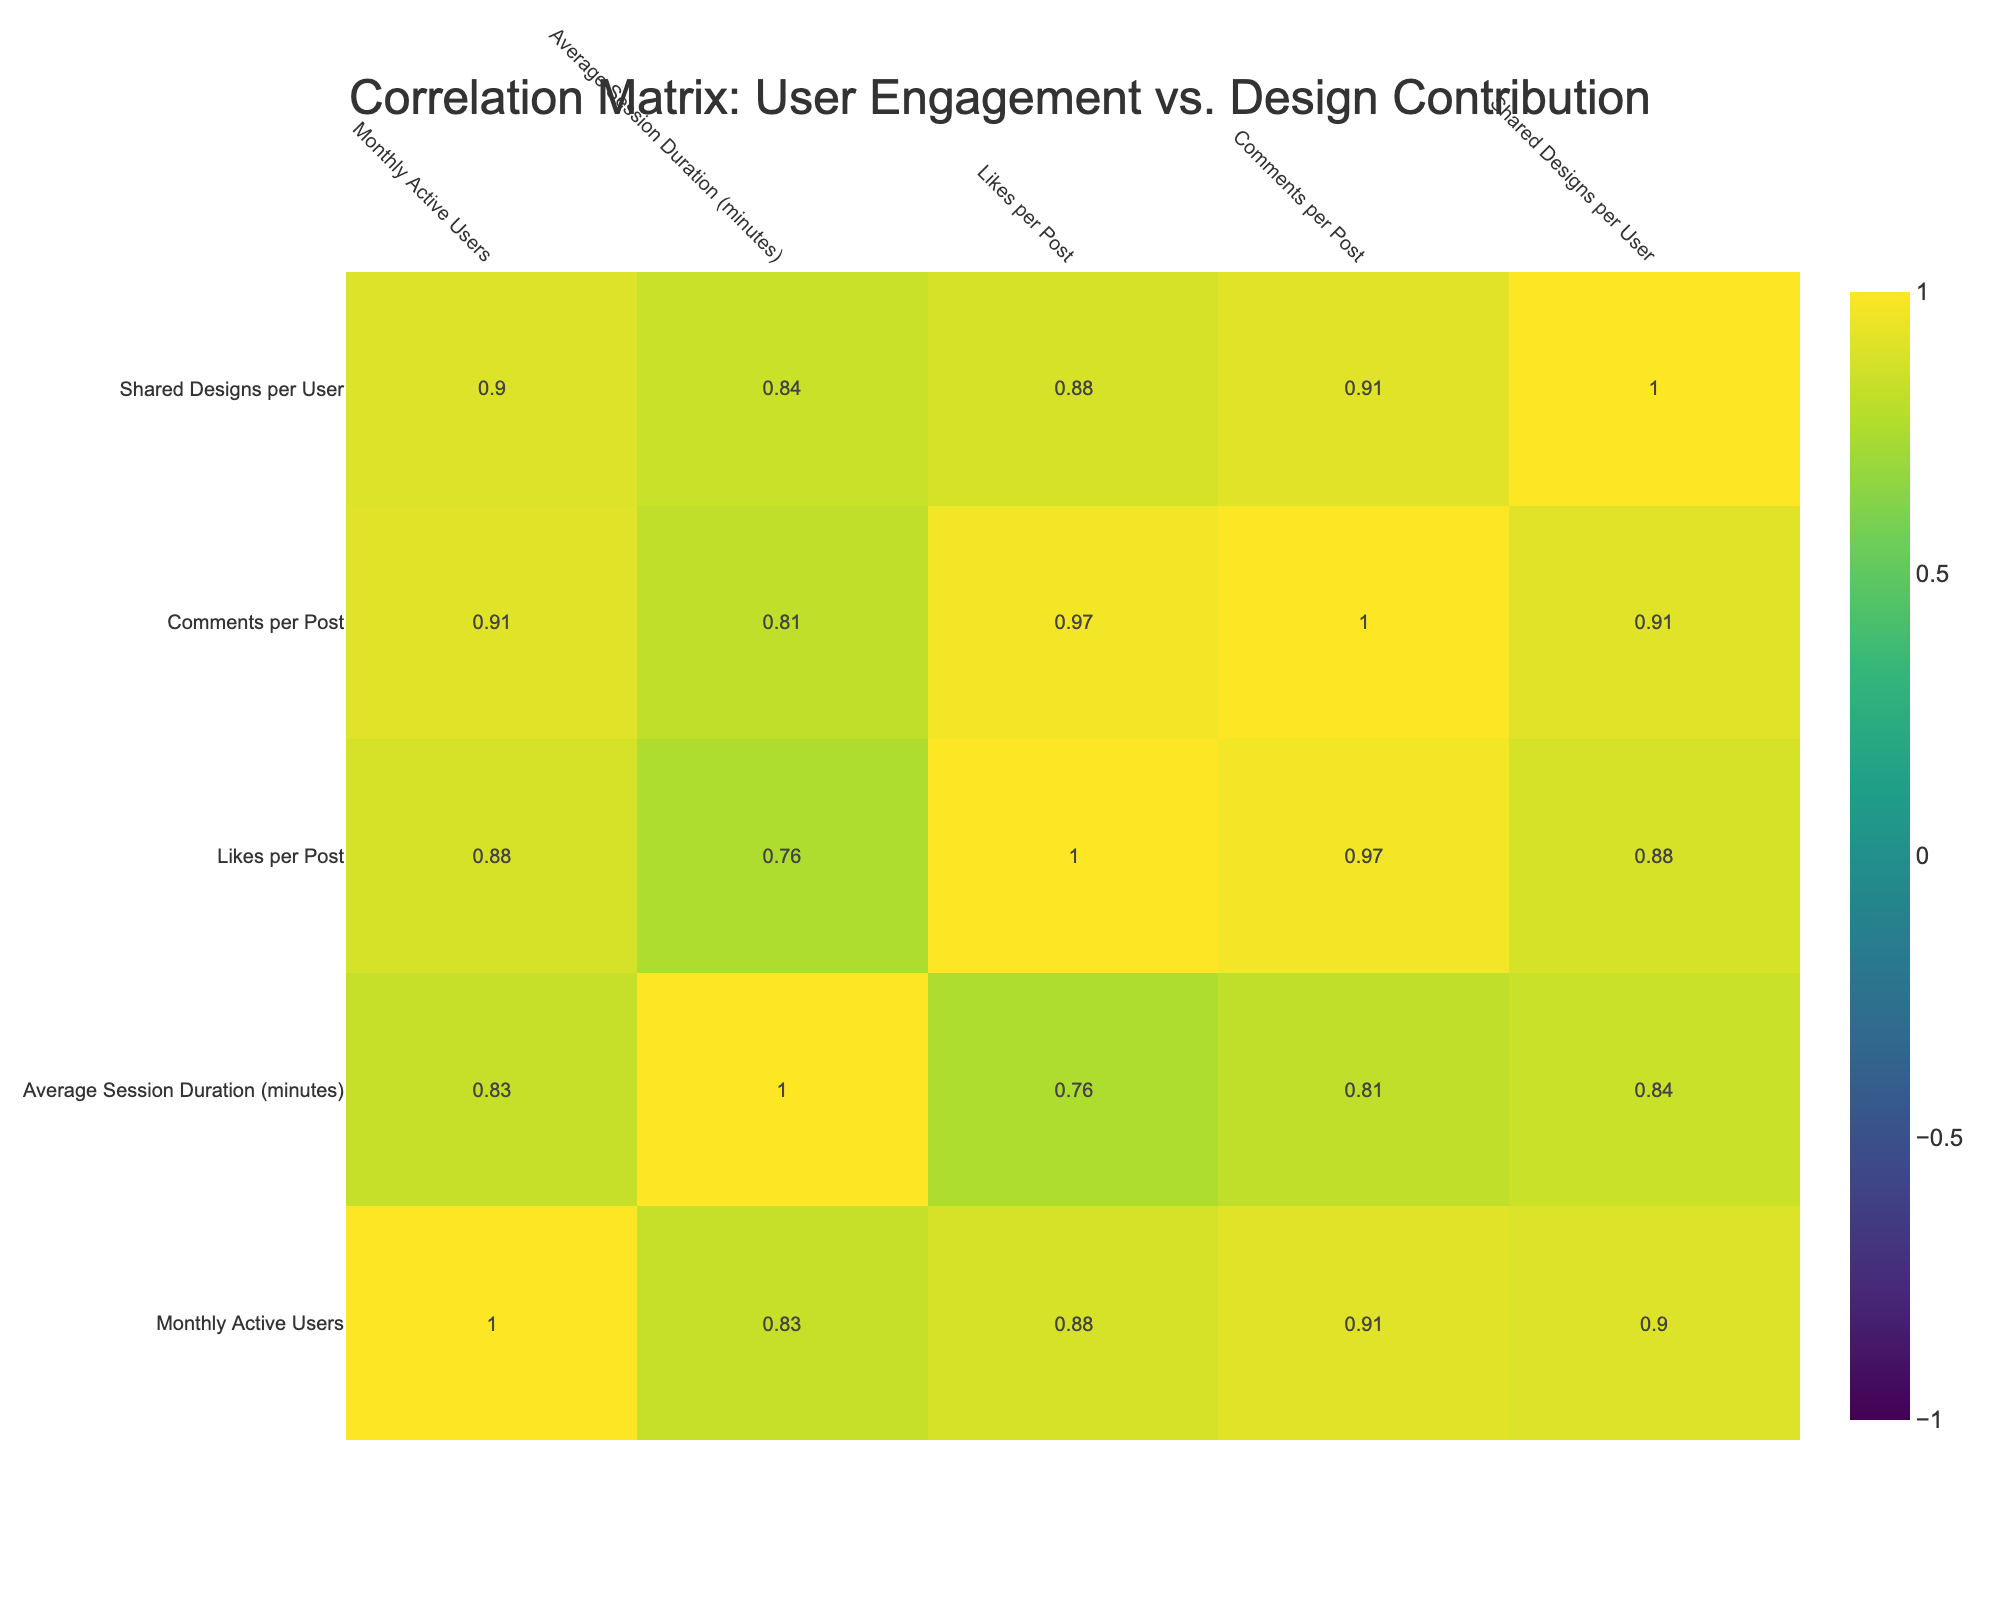What is the correlation between Likes per Post and Comments per Post? The correlation value can be found in the table where Likes per Post and Comments per Post intersect. By referencing the correlation matrix, the value is likely to be positive, indicating that as Likes per Post increase, Comments per Post also tends to increase.
Answer: Positive correlation Which platform has the highest average session duration? By scanning the table, I can see that InspoNetwork has the highest value in the Average Session Duration column, which is 30 minutes.
Answer: InspoNetwork What is the average number of Likes per Post across all platforms? To find this, I sum the Likes per Post values (50 + 80 + 60 + 100 + 70 + 90 + 40 + 75 = 565) and divide by the number of platforms (8). Thus, the average is 565/8 = 70.625, which rounds to 71.
Answer: 71 Is it true that GraphiConnect has more Shared Designs per User than DesignTribe? By comparing the Shared Designs per User values, GraphiConnect has 8 while DesignTribe has 5. Since 8 is greater than 5, the statement is true.
Answer: Yes What is the difference in Monthly Active Users between the platform with the most and the least users? First, I identify the platforms: InspoNetwork has the highest at 3000 Monthly Active Users, while DesignTribe has the lowest at 1300. The difference is 3000 - 1300 = 1700.
Answer: 1700 What is the relationship between Monthly Active Users and Shared Designs per User? To find this correlation, I look up the correlation coefficient from the table for these two metrics. If the value is positive, it indicates a trend where more active users lead to more shared designs, while a negative value would indicate the opposite trend.
Answer: Positive correlation Which platform ranks second in the number of Likes per Post, and what is that number? Looking at the Likes per Post column, the highest is 100 for InspoNetwork. The next highest value is 90 for PixelShare. Hence, PixelShare is the second and its Likes per Post is 90.
Answer: PixelShare, 90 What is the total number of Designs Shared by all users across all platforms? I sum the numbers of Shared Designs per User from each platform (10 + 15 + 12 + 20 + 8 + 18 + 5 + 10 = 98) to find the total.
Answer: 98 In what way does Average Session Duration relate to Likes per Post across the platforms? By checking the correlation in the table, a positive correlation means that as session durations increase, the likes received per post may also increase, suggesting that users who engage longer contribute more likes.
Answer: Positive correlation 